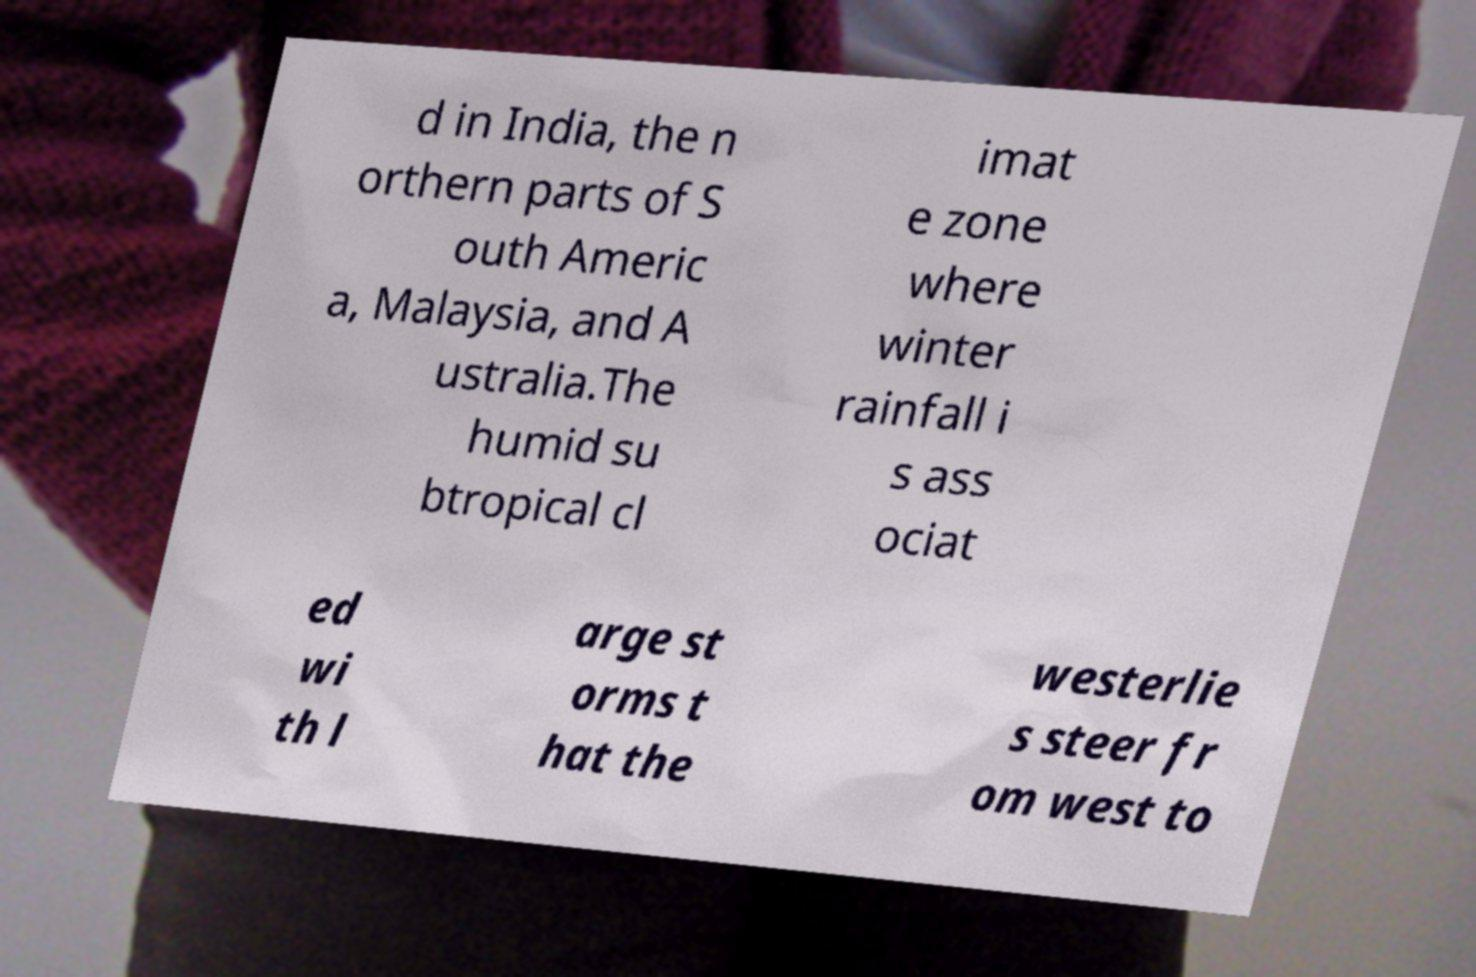Can you accurately transcribe the text from the provided image for me? d in India, the n orthern parts of S outh Americ a, Malaysia, and A ustralia.The humid su btropical cl imat e zone where winter rainfall i s ass ociat ed wi th l arge st orms t hat the westerlie s steer fr om west to 